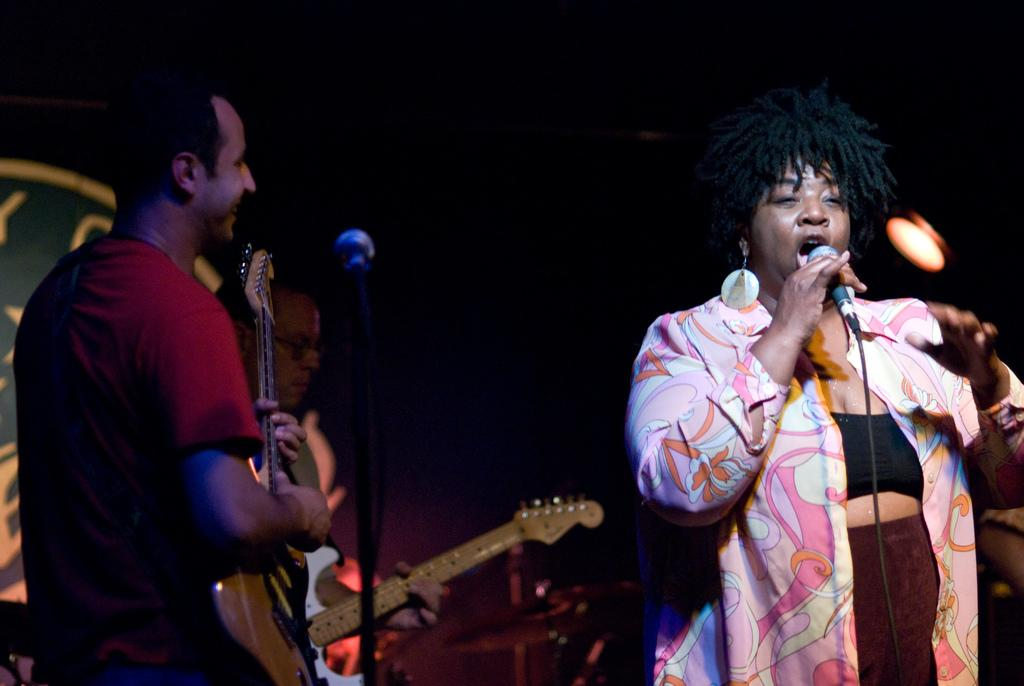Who is the main subject in the image? There is a woman in the image. What is the woman holding in the image? The woman is holding a microphone. How many men are in the image? There are two men in the image. What are the men holding in the image? Each man is holding a guitar. Are there any other microphones visible in the image? Yes, there is another microphone visible in the image. What type of story is being told by the woman in the image? There is no story being told in the image; the woman is holding a microphone, but there is no indication of a story being shared. 